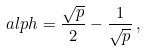<formula> <loc_0><loc_0><loc_500><loc_500>\ a l p h = \frac { \sqrt { p } } { 2 } - \frac { 1 } { \sqrt { p } } \, ,</formula> 